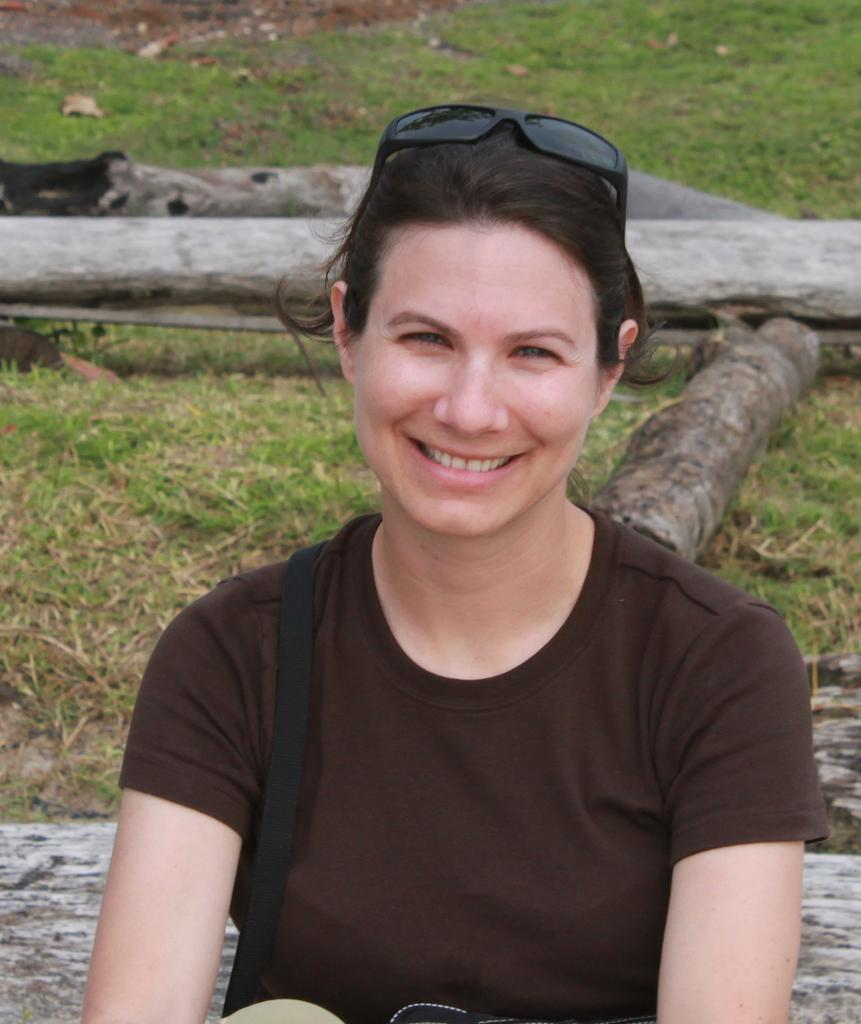Who is present in the image? There is a woman in the image. What is the woman's facial expression? The woman is smiling. What accessory is the woman wearing on her head? The woman is wearing goggles on her head. What type of natural environment can be seen in the background of the image? There is grass and wooden logs in the background of the image. How does the woman say good-bye to the skate in the image? There is no skate present in the image, and the woman is not interacting with any skate. 